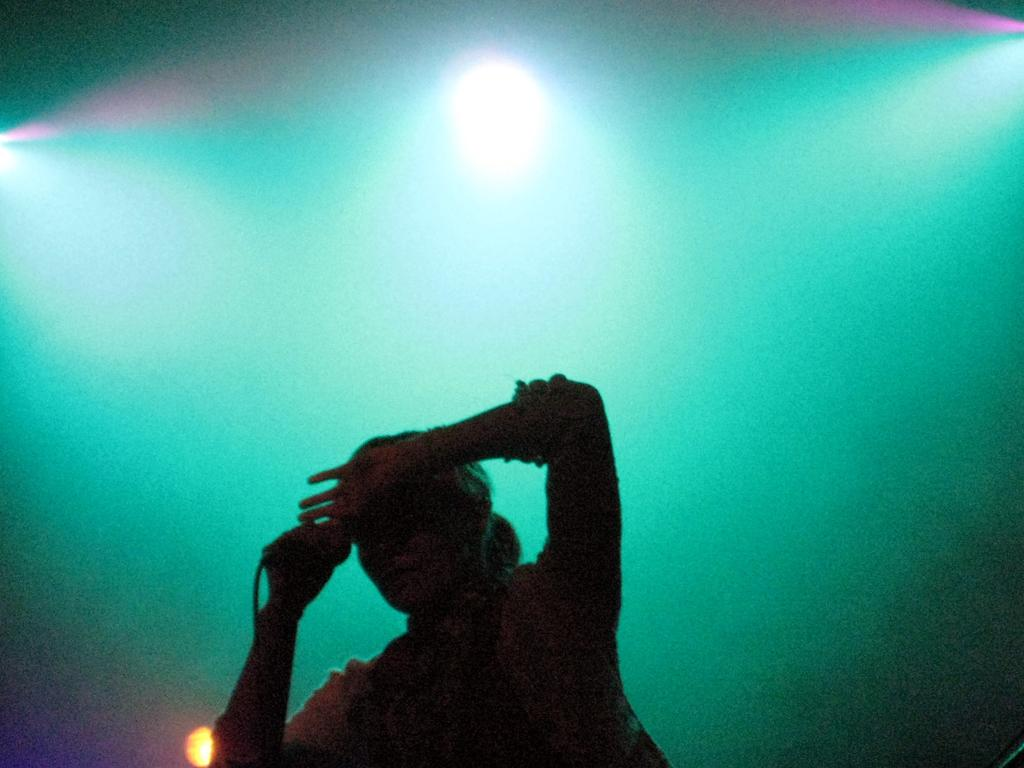What is the main subject of the image? There is a human in the image. What is the human holding in the image? The human is holding a microphone with a wire. What can be seen in the background of the image? There are lights visible in the background of the image. What type of mint is being used to clean the dust off the suit in the image? There is no mint, suit, or dust present in the image. 